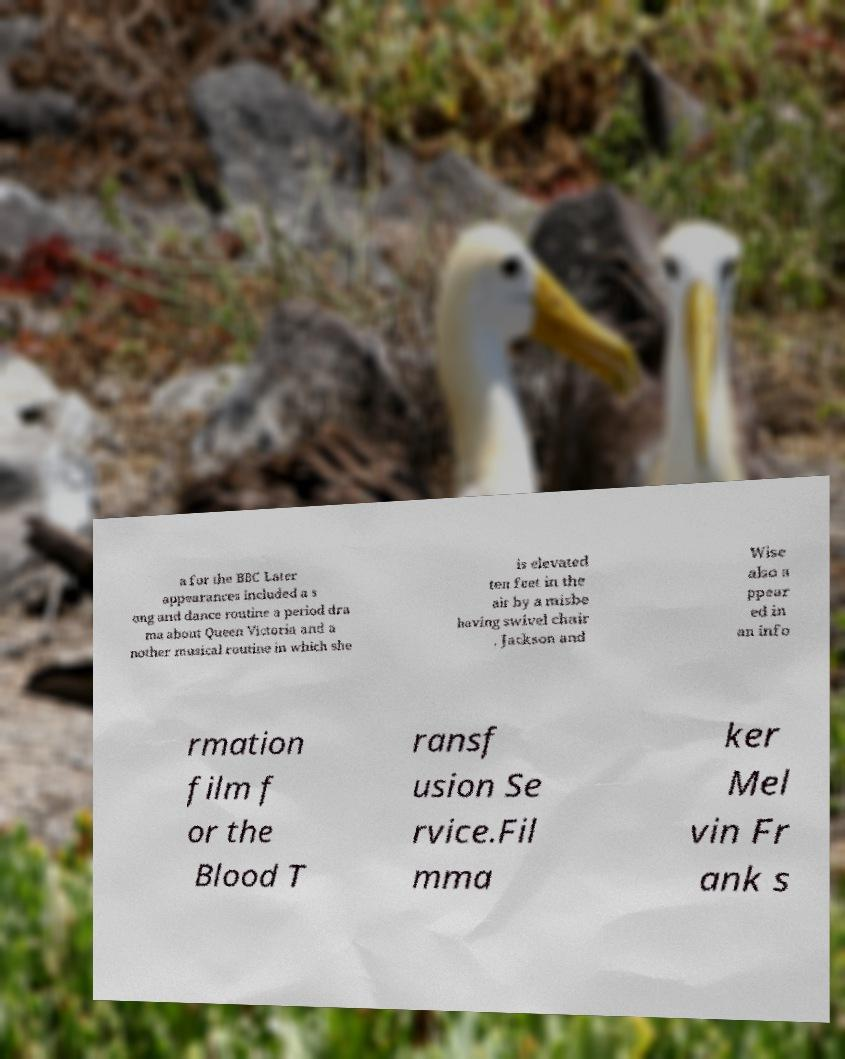Can you read and provide the text displayed in the image?This photo seems to have some interesting text. Can you extract and type it out for me? a for the BBC Later appearances included a s ong and dance routine a period dra ma about Queen Victoria and a nother musical routine in which she is elevated ten feet in the air by a misbe having swivel chair . Jackson and Wise also a ppear ed in an info rmation film f or the Blood T ransf usion Se rvice.Fil mma ker Mel vin Fr ank s 